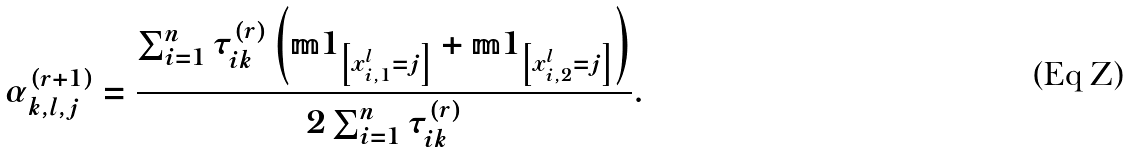Convert formula to latex. <formula><loc_0><loc_0><loc_500><loc_500>\alpha _ { k , l , j } ^ { \left ( r + 1 \right ) } = \frac { \sum _ { i = 1 } ^ { n } \tau _ { i k } ^ { \left ( r \right ) } \left ( \mathbb { m } { 1 } _ { \left [ x _ { i , 1 } ^ { l } = j \right ] } + \mathbb { m } { 1 } _ { \left [ x _ { i , 2 } ^ { l } = j \right ] } \right ) } { 2 \sum _ { i = 1 } ^ { n } \tau _ { i k } ^ { \left ( r \right ) } } .</formula> 